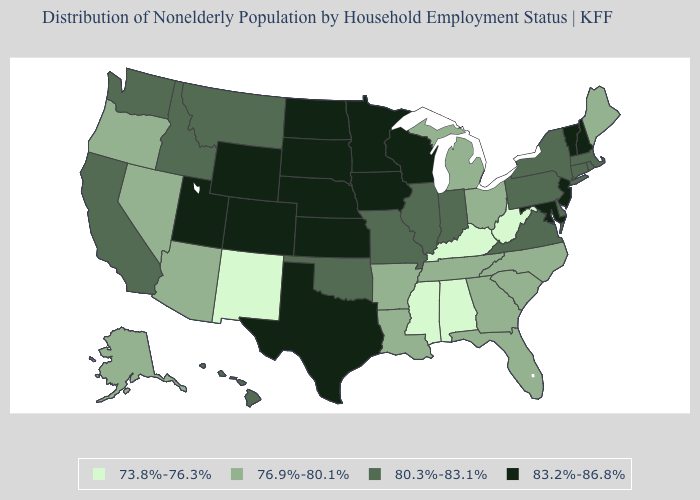What is the value of Utah?
Be succinct. 83.2%-86.8%. Name the states that have a value in the range 80.3%-83.1%?
Quick response, please. California, Connecticut, Delaware, Hawaii, Idaho, Illinois, Indiana, Massachusetts, Missouri, Montana, New York, Oklahoma, Pennsylvania, Rhode Island, Virginia, Washington. Name the states that have a value in the range 76.9%-80.1%?
Short answer required. Alaska, Arizona, Arkansas, Florida, Georgia, Louisiana, Maine, Michigan, Nevada, North Carolina, Ohio, Oregon, South Carolina, Tennessee. Does the first symbol in the legend represent the smallest category?
Quick response, please. Yes. Among the states that border Nebraska , does Kansas have the highest value?
Quick response, please. Yes. Does Ohio have the lowest value in the MidWest?
Concise answer only. Yes. Does North Carolina have a higher value than North Dakota?
Concise answer only. No. Does the first symbol in the legend represent the smallest category?
Concise answer only. Yes. Name the states that have a value in the range 83.2%-86.8%?
Concise answer only. Colorado, Iowa, Kansas, Maryland, Minnesota, Nebraska, New Hampshire, New Jersey, North Dakota, South Dakota, Texas, Utah, Vermont, Wisconsin, Wyoming. Which states hav the highest value in the West?
Give a very brief answer. Colorado, Utah, Wyoming. Among the states that border Michigan , does Wisconsin have the highest value?
Be succinct. Yes. Which states have the highest value in the USA?
Answer briefly. Colorado, Iowa, Kansas, Maryland, Minnesota, Nebraska, New Hampshire, New Jersey, North Dakota, South Dakota, Texas, Utah, Vermont, Wisconsin, Wyoming. What is the value of Rhode Island?
Keep it brief. 80.3%-83.1%. Name the states that have a value in the range 73.8%-76.3%?
Give a very brief answer. Alabama, Kentucky, Mississippi, New Mexico, West Virginia. Is the legend a continuous bar?
Short answer required. No. 